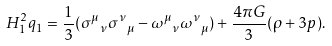Convert formula to latex. <formula><loc_0><loc_0><loc_500><loc_500>H _ { 1 } ^ { 2 } q _ { 1 } = \frac { 1 } { 3 } ( { \sigma ^ { \mu } } _ { \nu } { \sigma ^ { \nu } } _ { \mu } - { \omega ^ { \mu } } _ { \nu } { \omega ^ { \nu } } _ { \mu } ) + \frac { 4 \pi G } { 3 } ( \rho + 3 p ) .</formula> 